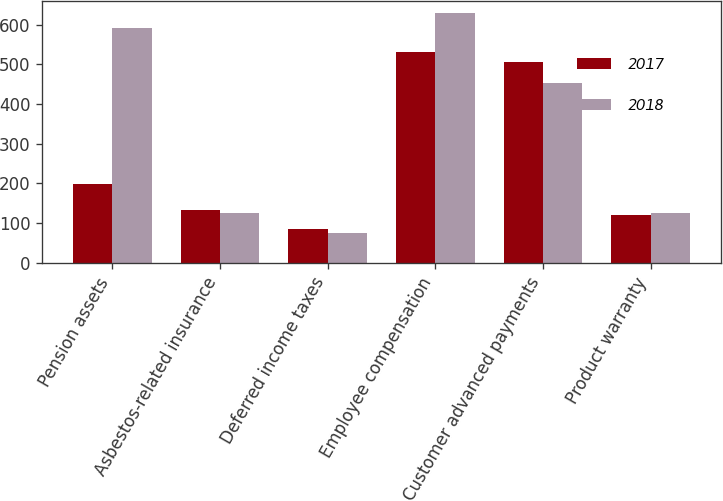<chart> <loc_0><loc_0><loc_500><loc_500><stacked_bar_chart><ecel><fcel>Pension assets<fcel>Asbestos-related insurance<fcel>Deferred income taxes<fcel>Employee compensation<fcel>Customer advanced payments<fcel>Product warranty<nl><fcel>2017<fcel>197<fcel>133<fcel>86<fcel>531<fcel>505<fcel>120<nl><fcel>2018<fcel>591<fcel>124<fcel>74<fcel>629<fcel>453<fcel>124<nl></chart> 